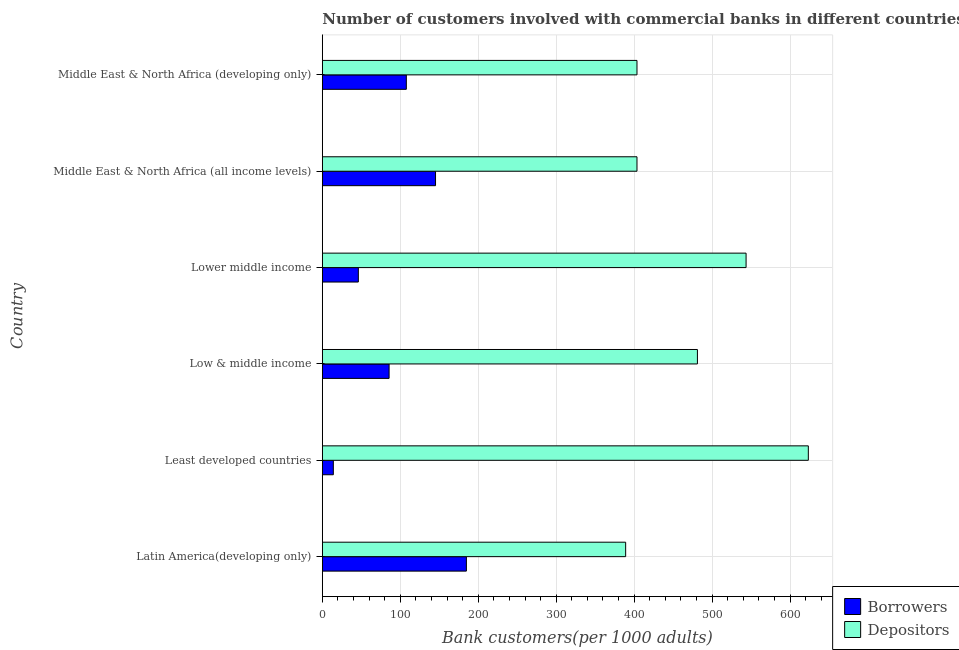How many different coloured bars are there?
Your answer should be compact. 2. How many bars are there on the 3rd tick from the top?
Keep it short and to the point. 2. What is the label of the 3rd group of bars from the top?
Offer a very short reply. Lower middle income. In how many cases, is the number of bars for a given country not equal to the number of legend labels?
Make the answer very short. 0. What is the number of borrowers in Lower middle income?
Ensure brevity in your answer.  46.19. Across all countries, what is the maximum number of borrowers?
Provide a short and direct response. 184.81. Across all countries, what is the minimum number of borrowers?
Give a very brief answer. 14.11. In which country was the number of depositors maximum?
Your answer should be compact. Least developed countries. In which country was the number of depositors minimum?
Provide a succinct answer. Latin America(developing only). What is the total number of depositors in the graph?
Provide a short and direct response. 2844.59. What is the difference between the number of borrowers in Low & middle income and that in Middle East & North Africa (developing only)?
Offer a terse response. -22.1. What is the difference between the number of depositors in Low & middle income and the number of borrowers in Middle East & North Africa (developing only)?
Keep it short and to the point. 373.42. What is the average number of borrowers per country?
Offer a terse response. 97.29. What is the difference between the number of borrowers and number of depositors in Least developed countries?
Your answer should be very brief. -609.34. What is the ratio of the number of borrowers in Least developed countries to that in Lower middle income?
Offer a very short reply. 0.3. Is the number of borrowers in Lower middle income less than that in Middle East & North Africa (all income levels)?
Ensure brevity in your answer.  Yes. Is the difference between the number of borrowers in Low & middle income and Middle East & North Africa (developing only) greater than the difference between the number of depositors in Low & middle income and Middle East & North Africa (developing only)?
Provide a short and direct response. No. What is the difference between the highest and the second highest number of depositors?
Give a very brief answer. 79.86. What is the difference between the highest and the lowest number of depositors?
Provide a succinct answer. 234.34. What does the 1st bar from the top in Middle East & North Africa (all income levels) represents?
Give a very brief answer. Depositors. What does the 1st bar from the bottom in Middle East & North Africa (all income levels) represents?
Make the answer very short. Borrowers. How many countries are there in the graph?
Your response must be concise. 6. What is the difference between two consecutive major ticks on the X-axis?
Offer a very short reply. 100. What is the title of the graph?
Provide a short and direct response. Number of customers involved with commercial banks in different countries. What is the label or title of the X-axis?
Your answer should be very brief. Bank customers(per 1000 adults). What is the label or title of the Y-axis?
Keep it short and to the point. Country. What is the Bank customers(per 1000 adults) in Borrowers in Latin America(developing only)?
Keep it short and to the point. 184.81. What is the Bank customers(per 1000 adults) of Depositors in Latin America(developing only)?
Make the answer very short. 389.11. What is the Bank customers(per 1000 adults) in Borrowers in Least developed countries?
Offer a terse response. 14.11. What is the Bank customers(per 1000 adults) of Depositors in Least developed countries?
Provide a short and direct response. 623.45. What is the Bank customers(per 1000 adults) of Borrowers in Low & middle income?
Offer a very short reply. 85.65. What is the Bank customers(per 1000 adults) in Depositors in Low & middle income?
Your answer should be very brief. 481.17. What is the Bank customers(per 1000 adults) in Borrowers in Lower middle income?
Ensure brevity in your answer.  46.19. What is the Bank customers(per 1000 adults) in Depositors in Lower middle income?
Your answer should be very brief. 543.59. What is the Bank customers(per 1000 adults) of Borrowers in Middle East & North Africa (all income levels)?
Ensure brevity in your answer.  145.22. What is the Bank customers(per 1000 adults) in Depositors in Middle East & North Africa (all income levels)?
Give a very brief answer. 403.64. What is the Bank customers(per 1000 adults) of Borrowers in Middle East & North Africa (developing only)?
Keep it short and to the point. 107.75. What is the Bank customers(per 1000 adults) in Depositors in Middle East & North Africa (developing only)?
Give a very brief answer. 403.64. Across all countries, what is the maximum Bank customers(per 1000 adults) in Borrowers?
Provide a short and direct response. 184.81. Across all countries, what is the maximum Bank customers(per 1000 adults) in Depositors?
Your answer should be compact. 623.45. Across all countries, what is the minimum Bank customers(per 1000 adults) of Borrowers?
Ensure brevity in your answer.  14.11. Across all countries, what is the minimum Bank customers(per 1000 adults) in Depositors?
Offer a very short reply. 389.11. What is the total Bank customers(per 1000 adults) of Borrowers in the graph?
Your answer should be very brief. 583.74. What is the total Bank customers(per 1000 adults) in Depositors in the graph?
Provide a short and direct response. 2844.59. What is the difference between the Bank customers(per 1000 adults) in Borrowers in Latin America(developing only) and that in Least developed countries?
Make the answer very short. 170.7. What is the difference between the Bank customers(per 1000 adults) in Depositors in Latin America(developing only) and that in Least developed countries?
Give a very brief answer. -234.34. What is the difference between the Bank customers(per 1000 adults) in Borrowers in Latin America(developing only) and that in Low & middle income?
Offer a very short reply. 99.15. What is the difference between the Bank customers(per 1000 adults) in Depositors in Latin America(developing only) and that in Low & middle income?
Make the answer very short. -92.06. What is the difference between the Bank customers(per 1000 adults) of Borrowers in Latin America(developing only) and that in Lower middle income?
Provide a succinct answer. 138.62. What is the difference between the Bank customers(per 1000 adults) of Depositors in Latin America(developing only) and that in Lower middle income?
Offer a terse response. -154.49. What is the difference between the Bank customers(per 1000 adults) of Borrowers in Latin America(developing only) and that in Middle East & North Africa (all income levels)?
Your answer should be very brief. 39.59. What is the difference between the Bank customers(per 1000 adults) in Depositors in Latin America(developing only) and that in Middle East & North Africa (all income levels)?
Give a very brief answer. -14.53. What is the difference between the Bank customers(per 1000 adults) of Borrowers in Latin America(developing only) and that in Middle East & North Africa (developing only)?
Provide a succinct answer. 77.06. What is the difference between the Bank customers(per 1000 adults) in Depositors in Latin America(developing only) and that in Middle East & North Africa (developing only)?
Give a very brief answer. -14.53. What is the difference between the Bank customers(per 1000 adults) in Borrowers in Least developed countries and that in Low & middle income?
Provide a succinct answer. -71.54. What is the difference between the Bank customers(per 1000 adults) in Depositors in Least developed countries and that in Low & middle income?
Ensure brevity in your answer.  142.28. What is the difference between the Bank customers(per 1000 adults) in Borrowers in Least developed countries and that in Lower middle income?
Give a very brief answer. -32.08. What is the difference between the Bank customers(per 1000 adults) in Depositors in Least developed countries and that in Lower middle income?
Your answer should be compact. 79.86. What is the difference between the Bank customers(per 1000 adults) of Borrowers in Least developed countries and that in Middle East & North Africa (all income levels)?
Give a very brief answer. -131.11. What is the difference between the Bank customers(per 1000 adults) of Depositors in Least developed countries and that in Middle East & North Africa (all income levels)?
Offer a terse response. 219.81. What is the difference between the Bank customers(per 1000 adults) of Borrowers in Least developed countries and that in Middle East & North Africa (developing only)?
Offer a terse response. -93.64. What is the difference between the Bank customers(per 1000 adults) in Depositors in Least developed countries and that in Middle East & North Africa (developing only)?
Keep it short and to the point. 219.81. What is the difference between the Bank customers(per 1000 adults) in Borrowers in Low & middle income and that in Lower middle income?
Provide a succinct answer. 39.46. What is the difference between the Bank customers(per 1000 adults) in Depositors in Low & middle income and that in Lower middle income?
Your response must be concise. -62.42. What is the difference between the Bank customers(per 1000 adults) in Borrowers in Low & middle income and that in Middle East & North Africa (all income levels)?
Keep it short and to the point. -59.57. What is the difference between the Bank customers(per 1000 adults) in Depositors in Low & middle income and that in Middle East & North Africa (all income levels)?
Ensure brevity in your answer.  77.53. What is the difference between the Bank customers(per 1000 adults) of Borrowers in Low & middle income and that in Middle East & North Africa (developing only)?
Give a very brief answer. -22.1. What is the difference between the Bank customers(per 1000 adults) in Depositors in Low & middle income and that in Middle East & North Africa (developing only)?
Offer a very short reply. 77.53. What is the difference between the Bank customers(per 1000 adults) of Borrowers in Lower middle income and that in Middle East & North Africa (all income levels)?
Your answer should be compact. -99.03. What is the difference between the Bank customers(per 1000 adults) in Depositors in Lower middle income and that in Middle East & North Africa (all income levels)?
Offer a terse response. 139.95. What is the difference between the Bank customers(per 1000 adults) in Borrowers in Lower middle income and that in Middle East & North Africa (developing only)?
Offer a very short reply. -61.56. What is the difference between the Bank customers(per 1000 adults) of Depositors in Lower middle income and that in Middle East & North Africa (developing only)?
Ensure brevity in your answer.  139.95. What is the difference between the Bank customers(per 1000 adults) of Borrowers in Middle East & North Africa (all income levels) and that in Middle East & North Africa (developing only)?
Make the answer very short. 37.47. What is the difference between the Bank customers(per 1000 adults) of Borrowers in Latin America(developing only) and the Bank customers(per 1000 adults) of Depositors in Least developed countries?
Provide a short and direct response. -438.64. What is the difference between the Bank customers(per 1000 adults) in Borrowers in Latin America(developing only) and the Bank customers(per 1000 adults) in Depositors in Low & middle income?
Offer a very short reply. -296.36. What is the difference between the Bank customers(per 1000 adults) of Borrowers in Latin America(developing only) and the Bank customers(per 1000 adults) of Depositors in Lower middle income?
Your answer should be compact. -358.78. What is the difference between the Bank customers(per 1000 adults) of Borrowers in Latin America(developing only) and the Bank customers(per 1000 adults) of Depositors in Middle East & North Africa (all income levels)?
Keep it short and to the point. -218.83. What is the difference between the Bank customers(per 1000 adults) of Borrowers in Latin America(developing only) and the Bank customers(per 1000 adults) of Depositors in Middle East & North Africa (developing only)?
Keep it short and to the point. -218.83. What is the difference between the Bank customers(per 1000 adults) of Borrowers in Least developed countries and the Bank customers(per 1000 adults) of Depositors in Low & middle income?
Offer a very short reply. -467.06. What is the difference between the Bank customers(per 1000 adults) of Borrowers in Least developed countries and the Bank customers(per 1000 adults) of Depositors in Lower middle income?
Make the answer very short. -529.48. What is the difference between the Bank customers(per 1000 adults) of Borrowers in Least developed countries and the Bank customers(per 1000 adults) of Depositors in Middle East & North Africa (all income levels)?
Keep it short and to the point. -389.53. What is the difference between the Bank customers(per 1000 adults) of Borrowers in Least developed countries and the Bank customers(per 1000 adults) of Depositors in Middle East & North Africa (developing only)?
Offer a very short reply. -389.53. What is the difference between the Bank customers(per 1000 adults) in Borrowers in Low & middle income and the Bank customers(per 1000 adults) in Depositors in Lower middle income?
Offer a terse response. -457.94. What is the difference between the Bank customers(per 1000 adults) of Borrowers in Low & middle income and the Bank customers(per 1000 adults) of Depositors in Middle East & North Africa (all income levels)?
Offer a terse response. -317.98. What is the difference between the Bank customers(per 1000 adults) of Borrowers in Low & middle income and the Bank customers(per 1000 adults) of Depositors in Middle East & North Africa (developing only)?
Your answer should be compact. -317.98. What is the difference between the Bank customers(per 1000 adults) in Borrowers in Lower middle income and the Bank customers(per 1000 adults) in Depositors in Middle East & North Africa (all income levels)?
Your answer should be very brief. -357.45. What is the difference between the Bank customers(per 1000 adults) of Borrowers in Lower middle income and the Bank customers(per 1000 adults) of Depositors in Middle East & North Africa (developing only)?
Your answer should be compact. -357.45. What is the difference between the Bank customers(per 1000 adults) in Borrowers in Middle East & North Africa (all income levels) and the Bank customers(per 1000 adults) in Depositors in Middle East & North Africa (developing only)?
Your response must be concise. -258.41. What is the average Bank customers(per 1000 adults) in Borrowers per country?
Offer a terse response. 97.29. What is the average Bank customers(per 1000 adults) in Depositors per country?
Your response must be concise. 474.1. What is the difference between the Bank customers(per 1000 adults) of Borrowers and Bank customers(per 1000 adults) of Depositors in Latin America(developing only)?
Offer a very short reply. -204.3. What is the difference between the Bank customers(per 1000 adults) of Borrowers and Bank customers(per 1000 adults) of Depositors in Least developed countries?
Provide a short and direct response. -609.34. What is the difference between the Bank customers(per 1000 adults) in Borrowers and Bank customers(per 1000 adults) in Depositors in Low & middle income?
Make the answer very short. -395.52. What is the difference between the Bank customers(per 1000 adults) of Borrowers and Bank customers(per 1000 adults) of Depositors in Lower middle income?
Offer a very short reply. -497.4. What is the difference between the Bank customers(per 1000 adults) of Borrowers and Bank customers(per 1000 adults) of Depositors in Middle East & North Africa (all income levels)?
Offer a terse response. -258.41. What is the difference between the Bank customers(per 1000 adults) in Borrowers and Bank customers(per 1000 adults) in Depositors in Middle East & North Africa (developing only)?
Offer a very short reply. -295.89. What is the ratio of the Bank customers(per 1000 adults) in Borrowers in Latin America(developing only) to that in Least developed countries?
Make the answer very short. 13.1. What is the ratio of the Bank customers(per 1000 adults) of Depositors in Latin America(developing only) to that in Least developed countries?
Make the answer very short. 0.62. What is the ratio of the Bank customers(per 1000 adults) in Borrowers in Latin America(developing only) to that in Low & middle income?
Provide a short and direct response. 2.16. What is the ratio of the Bank customers(per 1000 adults) in Depositors in Latin America(developing only) to that in Low & middle income?
Ensure brevity in your answer.  0.81. What is the ratio of the Bank customers(per 1000 adults) of Borrowers in Latin America(developing only) to that in Lower middle income?
Keep it short and to the point. 4. What is the ratio of the Bank customers(per 1000 adults) of Depositors in Latin America(developing only) to that in Lower middle income?
Offer a terse response. 0.72. What is the ratio of the Bank customers(per 1000 adults) in Borrowers in Latin America(developing only) to that in Middle East & North Africa (all income levels)?
Offer a very short reply. 1.27. What is the ratio of the Bank customers(per 1000 adults) in Borrowers in Latin America(developing only) to that in Middle East & North Africa (developing only)?
Your answer should be very brief. 1.72. What is the ratio of the Bank customers(per 1000 adults) in Borrowers in Least developed countries to that in Low & middle income?
Give a very brief answer. 0.16. What is the ratio of the Bank customers(per 1000 adults) in Depositors in Least developed countries to that in Low & middle income?
Offer a terse response. 1.3. What is the ratio of the Bank customers(per 1000 adults) in Borrowers in Least developed countries to that in Lower middle income?
Offer a very short reply. 0.31. What is the ratio of the Bank customers(per 1000 adults) in Depositors in Least developed countries to that in Lower middle income?
Provide a short and direct response. 1.15. What is the ratio of the Bank customers(per 1000 adults) in Borrowers in Least developed countries to that in Middle East & North Africa (all income levels)?
Offer a terse response. 0.1. What is the ratio of the Bank customers(per 1000 adults) in Depositors in Least developed countries to that in Middle East & North Africa (all income levels)?
Your answer should be very brief. 1.54. What is the ratio of the Bank customers(per 1000 adults) in Borrowers in Least developed countries to that in Middle East & North Africa (developing only)?
Your answer should be compact. 0.13. What is the ratio of the Bank customers(per 1000 adults) in Depositors in Least developed countries to that in Middle East & North Africa (developing only)?
Your answer should be compact. 1.54. What is the ratio of the Bank customers(per 1000 adults) of Borrowers in Low & middle income to that in Lower middle income?
Make the answer very short. 1.85. What is the ratio of the Bank customers(per 1000 adults) in Depositors in Low & middle income to that in Lower middle income?
Give a very brief answer. 0.89. What is the ratio of the Bank customers(per 1000 adults) of Borrowers in Low & middle income to that in Middle East & North Africa (all income levels)?
Ensure brevity in your answer.  0.59. What is the ratio of the Bank customers(per 1000 adults) in Depositors in Low & middle income to that in Middle East & North Africa (all income levels)?
Ensure brevity in your answer.  1.19. What is the ratio of the Bank customers(per 1000 adults) in Borrowers in Low & middle income to that in Middle East & North Africa (developing only)?
Make the answer very short. 0.79. What is the ratio of the Bank customers(per 1000 adults) in Depositors in Low & middle income to that in Middle East & North Africa (developing only)?
Provide a short and direct response. 1.19. What is the ratio of the Bank customers(per 1000 adults) in Borrowers in Lower middle income to that in Middle East & North Africa (all income levels)?
Your answer should be compact. 0.32. What is the ratio of the Bank customers(per 1000 adults) in Depositors in Lower middle income to that in Middle East & North Africa (all income levels)?
Your response must be concise. 1.35. What is the ratio of the Bank customers(per 1000 adults) in Borrowers in Lower middle income to that in Middle East & North Africa (developing only)?
Give a very brief answer. 0.43. What is the ratio of the Bank customers(per 1000 adults) of Depositors in Lower middle income to that in Middle East & North Africa (developing only)?
Make the answer very short. 1.35. What is the ratio of the Bank customers(per 1000 adults) in Borrowers in Middle East & North Africa (all income levels) to that in Middle East & North Africa (developing only)?
Your answer should be very brief. 1.35. What is the difference between the highest and the second highest Bank customers(per 1000 adults) of Borrowers?
Offer a terse response. 39.59. What is the difference between the highest and the second highest Bank customers(per 1000 adults) of Depositors?
Provide a short and direct response. 79.86. What is the difference between the highest and the lowest Bank customers(per 1000 adults) in Borrowers?
Make the answer very short. 170.7. What is the difference between the highest and the lowest Bank customers(per 1000 adults) in Depositors?
Provide a short and direct response. 234.34. 